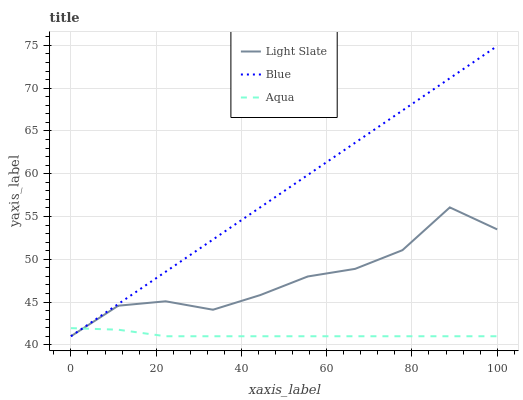Does Aqua have the minimum area under the curve?
Answer yes or no. Yes. Does Blue have the maximum area under the curve?
Answer yes or no. Yes. Does Blue have the minimum area under the curve?
Answer yes or no. No. Does Aqua have the maximum area under the curve?
Answer yes or no. No. Is Blue the smoothest?
Answer yes or no. Yes. Is Light Slate the roughest?
Answer yes or no. Yes. Is Aqua the smoothest?
Answer yes or no. No. Is Aqua the roughest?
Answer yes or no. No. Does Light Slate have the lowest value?
Answer yes or no. Yes. Does Blue have the highest value?
Answer yes or no. Yes. Does Aqua have the highest value?
Answer yes or no. No. Does Light Slate intersect Aqua?
Answer yes or no. Yes. Is Light Slate less than Aqua?
Answer yes or no. No. Is Light Slate greater than Aqua?
Answer yes or no. No. 